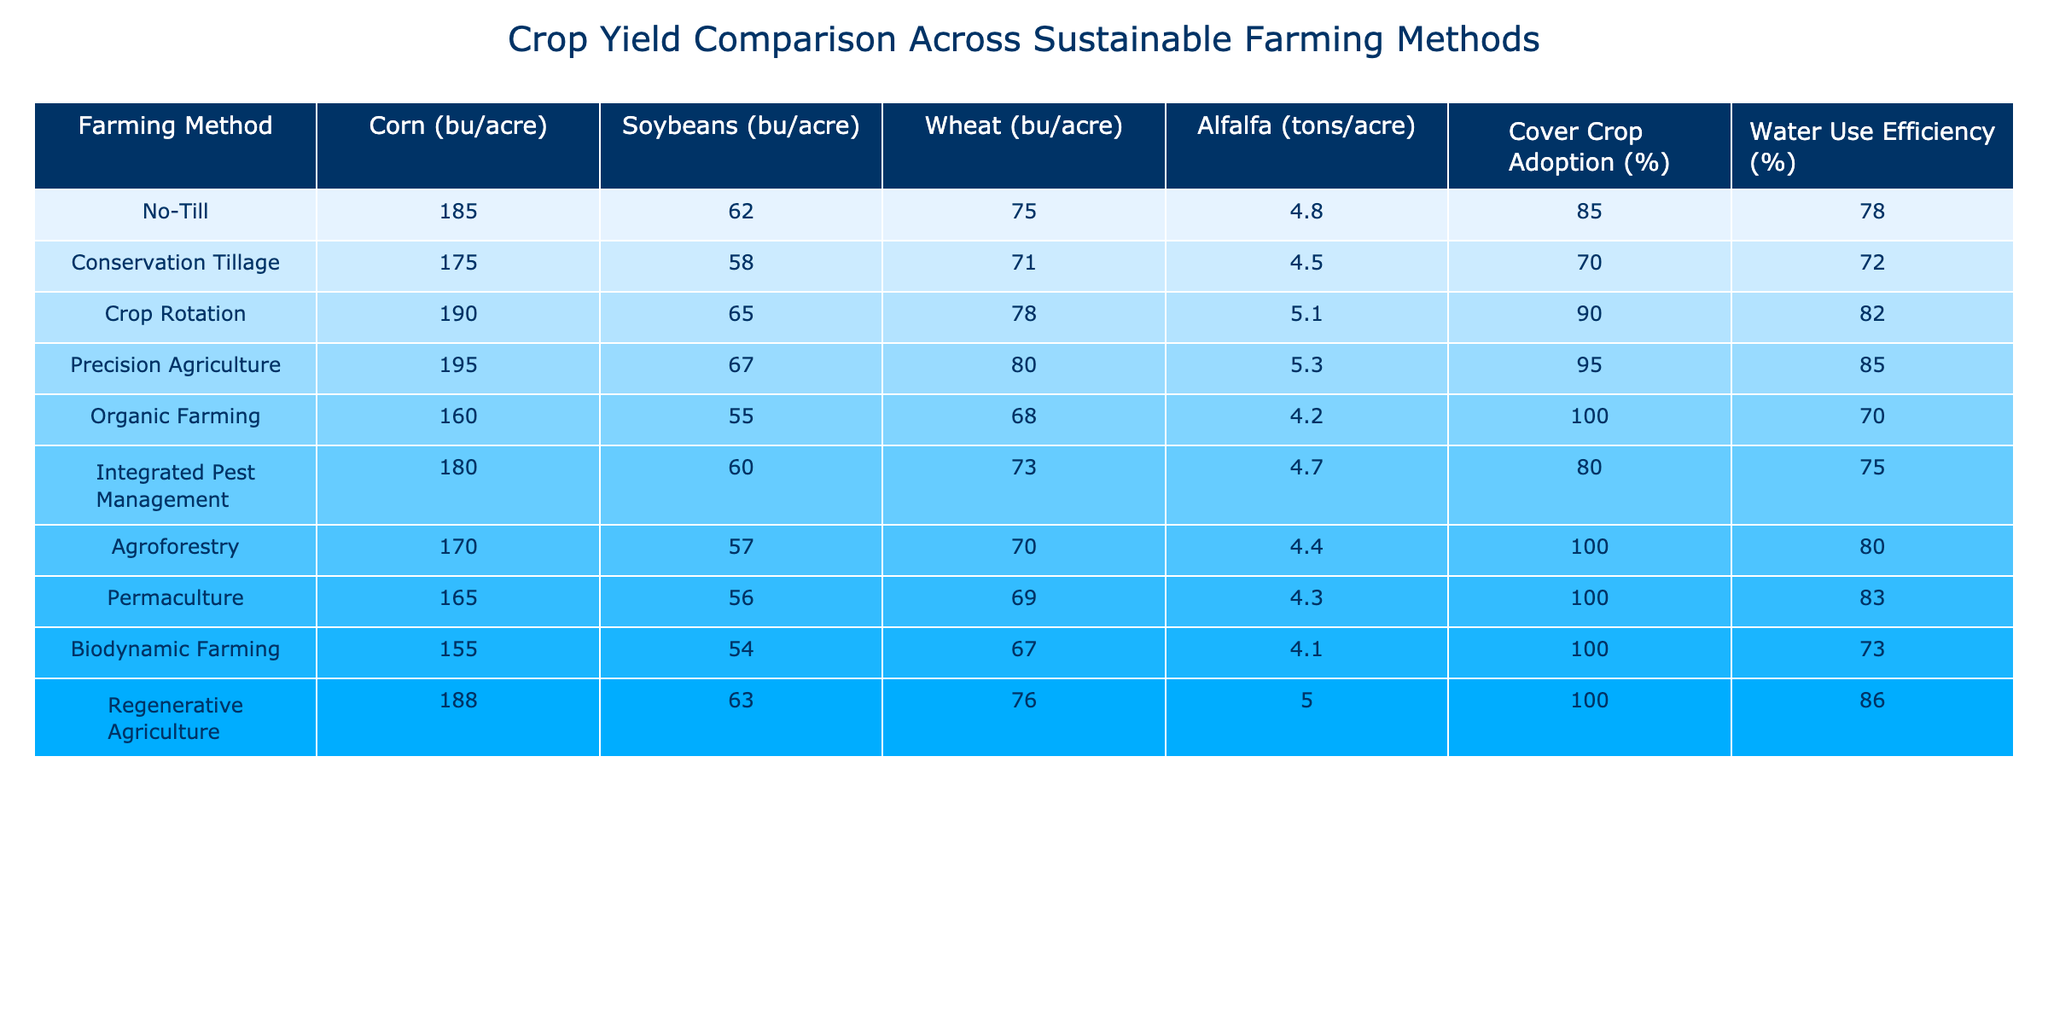What is the corn yield for the Precision Agriculture method? The table shows the corn yield for the Precision Agriculture method in the column labeled "Corn (bu/acre)," which indicates 195 bushels per acre.
Answer: 195 Which farming method has the highest soybean yield? By examining the soybean yields in the table, the Precision Agriculture method has the highest value at 67 bushels per acre.
Answer: 67 What is the average wheat yield across all farming methods? The wheat yields from the table are: 75, 71, 78, 80, 68, 73, 70, 69, 67, and 76. The sum is  75 + 71 + 78 + 80 + 68 + 73 + 70 + 69 + 67 + 76 =  758. There are 10 methods, so the average wheat yield is 758 / 10 = 75.8 bushels per acre.
Answer: 75.8 Is the cover crop adoption percentage higher for Regenerative Agriculture compared to Organic Farming? The cover crop adoption percentage for Regenerative Agriculture is 100%, while for Organic Farming, it is 100% as well. Therefore, they are equal, and the answer is no.
Answer: No What is the difference in water use efficiency between Crop Rotation and Organic Farming? The water use efficiency for Crop Rotation is 82% and for Organic Farming is 70%. Calculating the difference gives 82 - 70 = 12%.
Answer: 12 Which farming method has the best water use efficiency and how much is it? Looking at the water use efficiency column, Precision Agriculture has the highest value at 85%.
Answer: 85 True or False: Cover Crop Adoption is greater than 90% for all farming methods listed in the table. By checking the cover crop adoption percentages, we see that Organic Farming, No-Till, Conservation Tillage, and Agroforestry have values less than 90%, so the statement is false.
Answer: False Which farming methods have a corn yield greater than the average corn yield across all methods? First, we find the average corn yield: (185 + 175 + 190 + 195 + 160 + 180 + 170 + 165 + 155 + 188) / 10 = 177.5. The methods with corn yields greater than this average are Precision Agriculture (195), Crop Rotation (190), and Regenerative Agriculture (188).
Answer: 3 methods How does the Alfalfa yield of Conservation Tillage compare to that of Regenerative Agriculture? Conservation Tillage has an alfalfa yield of 4.5 tons per acre, while Regenerative Agriculture has a yield of 5.0 tons per acre. The difference shows that Regenerative Agriculture yields 0.5 tons more per acre.
Answer: 0.5 tons more What farming methods show a corn yield above 180 bu/acre? The methods that have corn yields above 180 bu/acre are Precision Agriculture (195), Crop Rotation (190), and Regenerative Agriculture (188).
Answer: 3 methods 